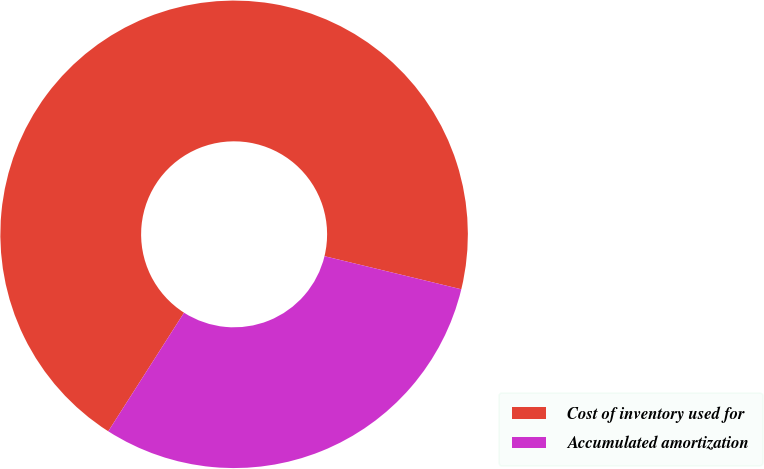Convert chart to OTSL. <chart><loc_0><loc_0><loc_500><loc_500><pie_chart><fcel>Cost of inventory used for<fcel>Accumulated amortization<nl><fcel>69.73%<fcel>30.27%<nl></chart> 